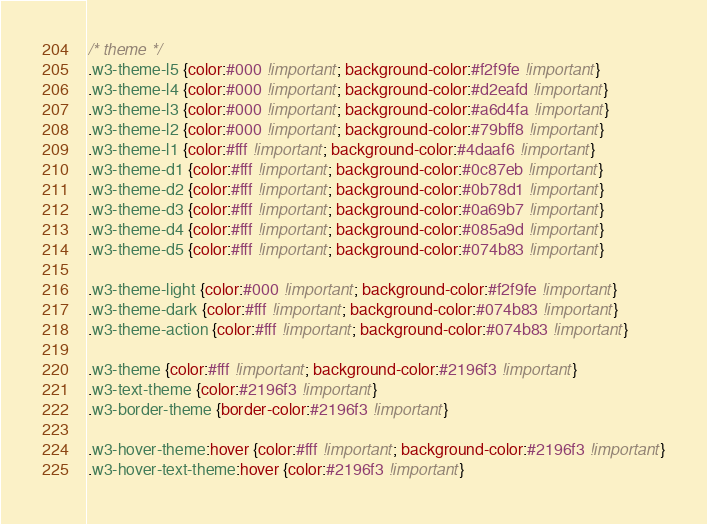<code> <loc_0><loc_0><loc_500><loc_500><_CSS_>/* theme */
.w3-theme-l5 {color:#000 !important; background-color:#f2f9fe !important}
.w3-theme-l4 {color:#000 !important; background-color:#d2eafd !important}
.w3-theme-l3 {color:#000 !important; background-color:#a6d4fa !important}
.w3-theme-l2 {color:#000 !important; background-color:#79bff8 !important}
.w3-theme-l1 {color:#fff !important; background-color:#4daaf6 !important}
.w3-theme-d1 {color:#fff !important; background-color:#0c87eb !important}
.w3-theme-d2 {color:#fff !important; background-color:#0b78d1 !important}
.w3-theme-d3 {color:#fff !important; background-color:#0a69b7 !important}
.w3-theme-d4 {color:#fff !important; background-color:#085a9d !important}
.w3-theme-d5 {color:#fff !important; background-color:#074b83 !important}

.w3-theme-light {color:#000 !important; background-color:#f2f9fe !important}
.w3-theme-dark {color:#fff !important; background-color:#074b83 !important}
.w3-theme-action {color:#fff !important; background-color:#074b83 !important}

.w3-theme {color:#fff !important; background-color:#2196f3 !important}
.w3-text-theme {color:#2196f3 !important}
.w3-border-theme {border-color:#2196f3 !important}

.w3-hover-theme:hover {color:#fff !important; background-color:#2196f3 !important}
.w3-hover-text-theme:hover {color:#2196f3 !important}</code> 